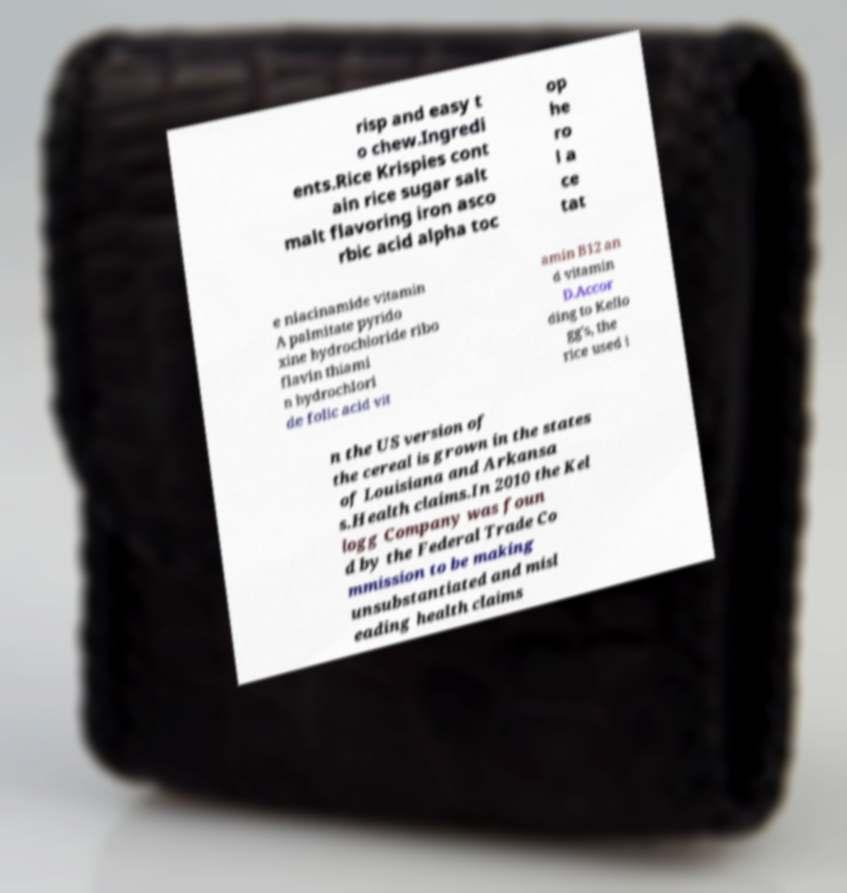Can you accurately transcribe the text from the provided image for me? risp and easy t o chew.Ingredi ents.Rice Krispies cont ain rice sugar salt malt flavoring iron asco rbic acid alpha toc op he ro l a ce tat e niacinamide vitamin A palmitate pyrido xine hydrochloride ribo flavin thiami n hydrochlori de folic acid vit amin B12 an d vitamin D.Accor ding to Kello gg's, the rice used i n the US version of the cereal is grown in the states of Louisiana and Arkansa s.Health claims.In 2010 the Kel logg Company was foun d by the Federal Trade Co mmission to be making unsubstantiated and misl eading health claims 